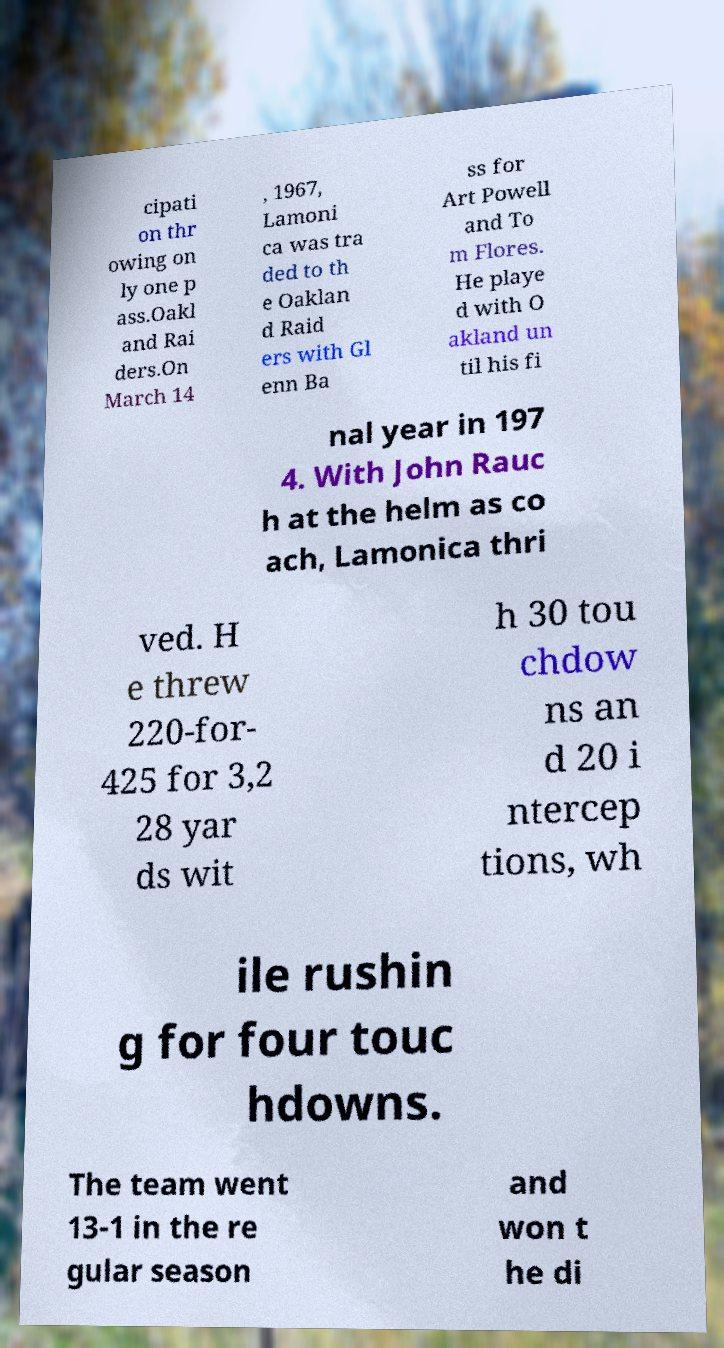What messages or text are displayed in this image? I need them in a readable, typed format. cipati on thr owing on ly one p ass.Oakl and Rai ders.On March 14 , 1967, Lamoni ca was tra ded to th e Oaklan d Raid ers with Gl enn Ba ss for Art Powell and To m Flores. He playe d with O akland un til his fi nal year in 197 4. With John Rauc h at the helm as co ach, Lamonica thri ved. H e threw 220-for- 425 for 3,2 28 yar ds wit h 30 tou chdow ns an d 20 i ntercep tions, wh ile rushin g for four touc hdowns. The team went 13-1 in the re gular season and won t he di 